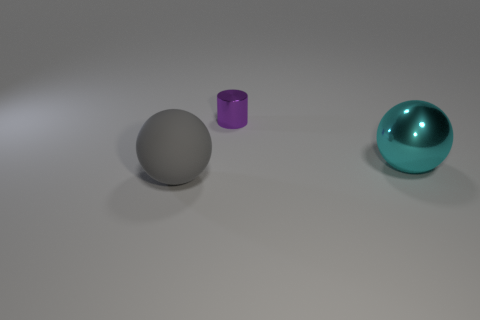Is there any other thing that has the same shape as the small purple shiny thing?
Your answer should be compact. No. Are there any other metallic cylinders that have the same size as the purple metallic cylinder?
Your response must be concise. No. There is a ball to the right of the ball that is to the left of the purple cylinder; what color is it?
Your answer should be compact. Cyan. How many big gray objects are there?
Provide a succinct answer. 1. Are there fewer large rubber balls that are behind the tiny metal cylinder than large gray matte objects behind the matte ball?
Provide a short and direct response. No. The large matte thing is what color?
Provide a succinct answer. Gray. Are there any metal spheres on the right side of the big cyan metal thing?
Your answer should be compact. No. Are there the same number of large rubber objects behind the matte ball and cyan metallic balls that are left of the shiny ball?
Keep it short and to the point. Yes. Is the size of the ball right of the gray sphere the same as the shiny object that is behind the large cyan metal object?
Provide a succinct answer. No. The large thing that is on the right side of the sphere that is left of the large sphere that is on the right side of the tiny purple metallic object is what shape?
Your answer should be compact. Sphere. 